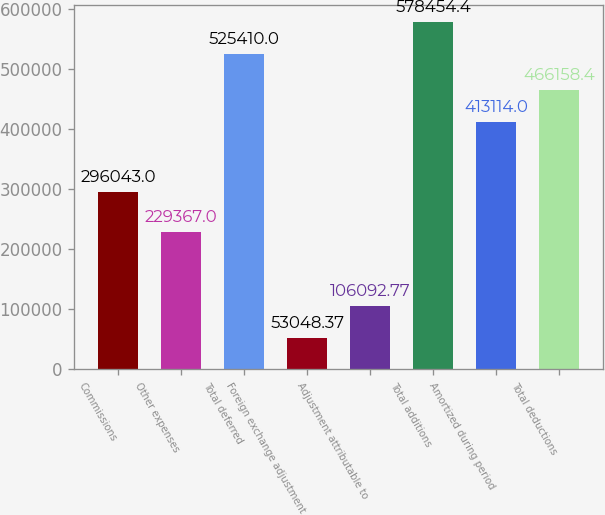Convert chart to OTSL. <chart><loc_0><loc_0><loc_500><loc_500><bar_chart><fcel>Commissions<fcel>Other expenses<fcel>Total deferred<fcel>Foreign exchange adjustment<fcel>Adjustment attributable to<fcel>Total additions<fcel>Amortized during period<fcel>Total deductions<nl><fcel>296043<fcel>229367<fcel>525410<fcel>53048.4<fcel>106093<fcel>578454<fcel>413114<fcel>466158<nl></chart> 